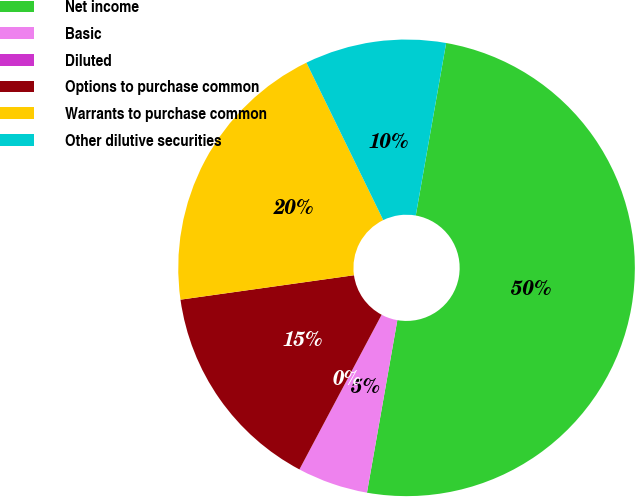Convert chart to OTSL. <chart><loc_0><loc_0><loc_500><loc_500><pie_chart><fcel>Net income<fcel>Basic<fcel>Diluted<fcel>Options to purchase common<fcel>Warrants to purchase common<fcel>Other dilutive securities<nl><fcel>50.0%<fcel>5.0%<fcel>0.0%<fcel>15.0%<fcel>20.0%<fcel>10.0%<nl></chart> 